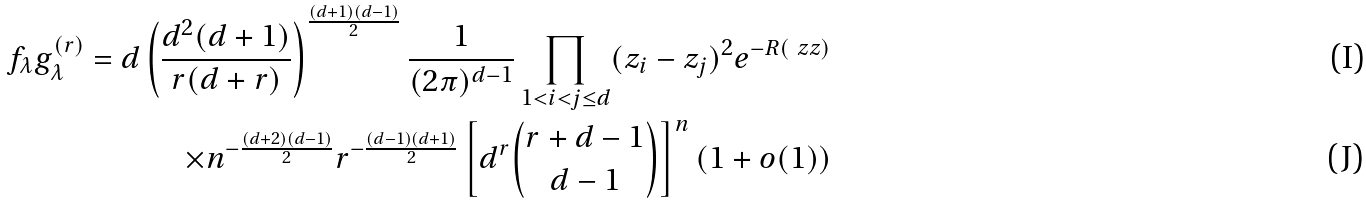<formula> <loc_0><loc_0><loc_500><loc_500>f _ { \lambda } g _ { \lambda } ^ { ( r ) } = d \left ( \frac { d ^ { 2 } ( d + 1 ) } { r ( d + r ) } \right ) ^ { \frac { ( d + 1 ) ( d - 1 ) } { 2 } } \frac { 1 } { ( 2 \pi ) ^ { d - 1 } } \prod _ { 1 < i < j \leq d } ( z _ { i } - z _ { j } ) ^ { 2 } e ^ { - R ( \ z z ) } \\ \times n ^ { - \frac { ( d + 2 ) ( d - 1 ) } { 2 } } r ^ { - \frac { ( d - 1 ) ( d + 1 ) } { 2 } } \left [ d ^ { r } { r + d - 1 \choose d - 1 } \right ] ^ { n } ( 1 + o ( 1 ) )</formula> 